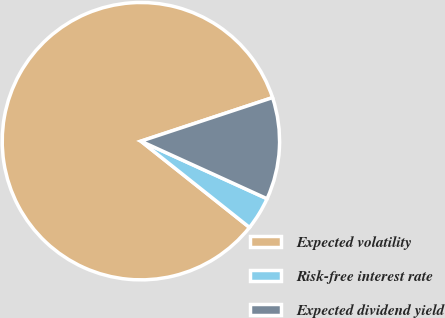Convert chart to OTSL. <chart><loc_0><loc_0><loc_500><loc_500><pie_chart><fcel>Expected volatility<fcel>Risk-free interest rate<fcel>Expected dividend yield<nl><fcel>84.23%<fcel>3.87%<fcel>11.9%<nl></chart> 